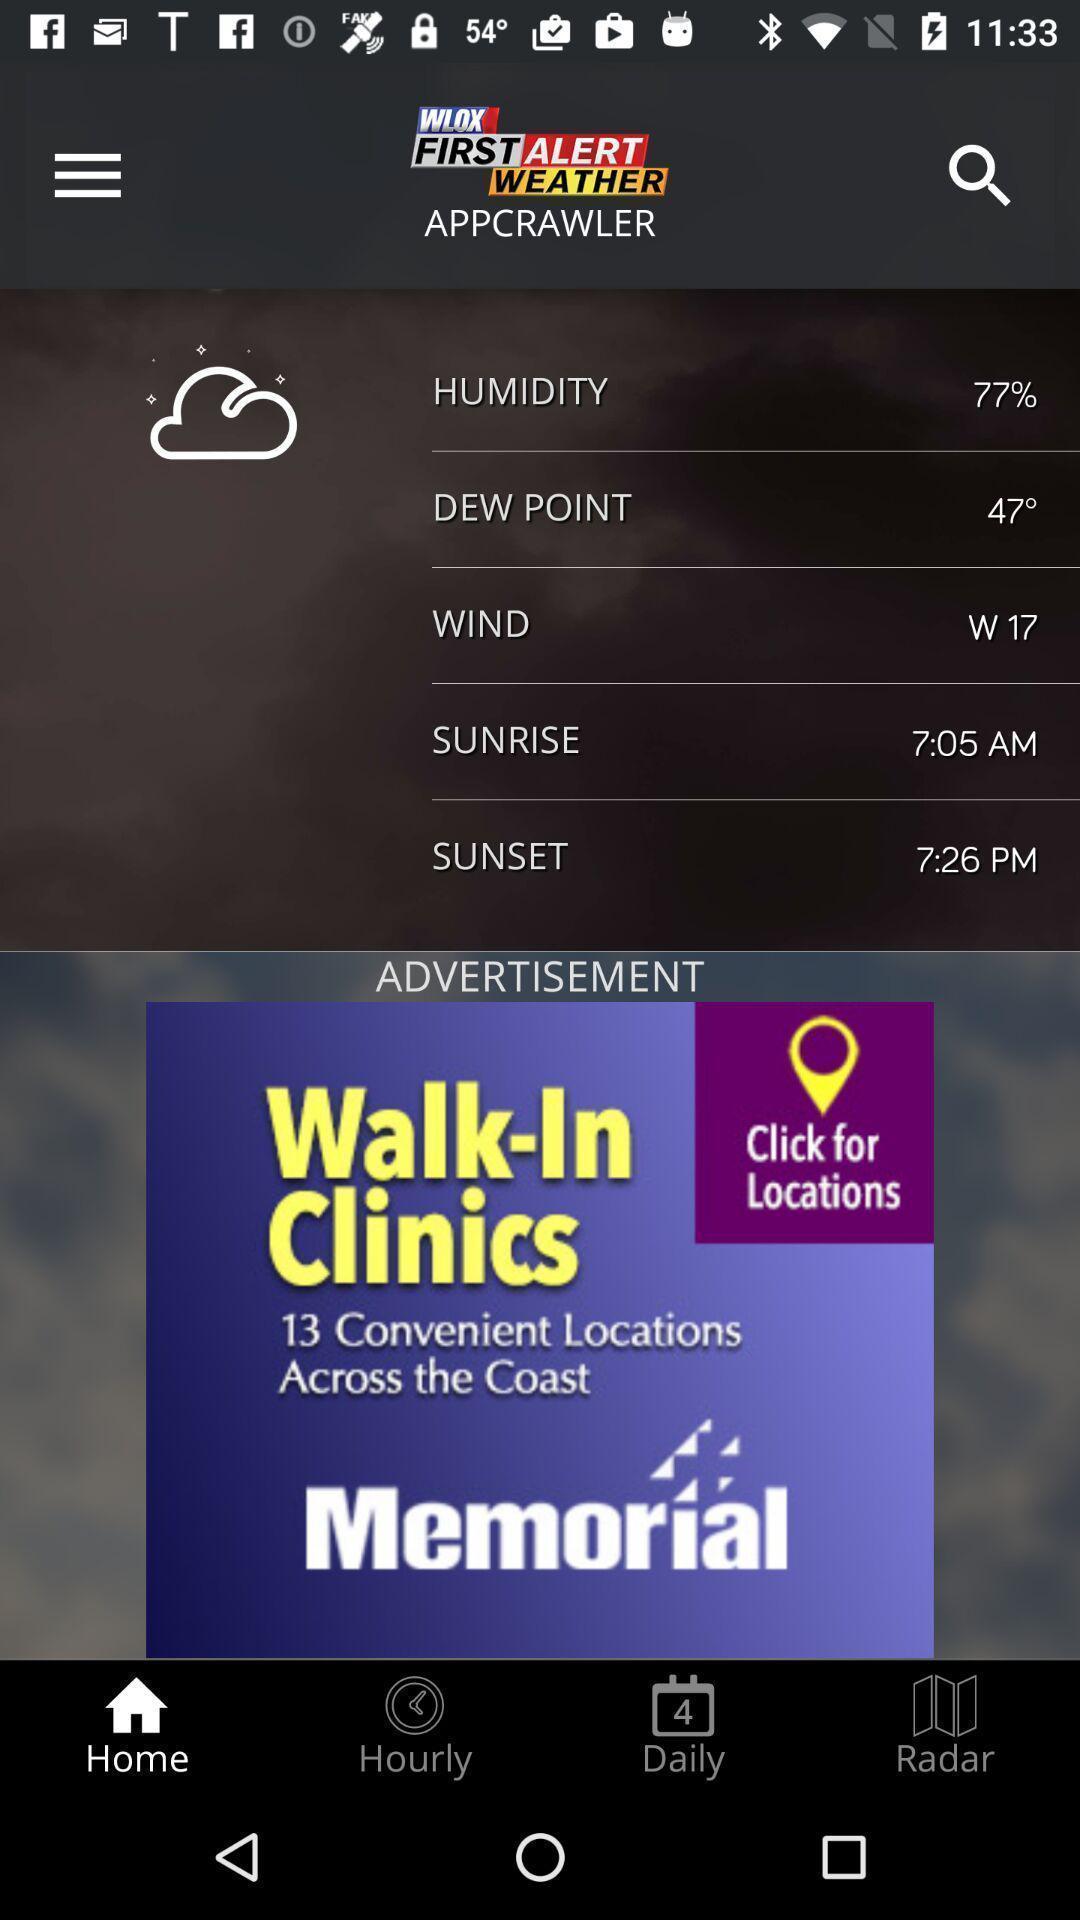Tell me what you see in this picture. Page shows the various weather information details on weather app. 